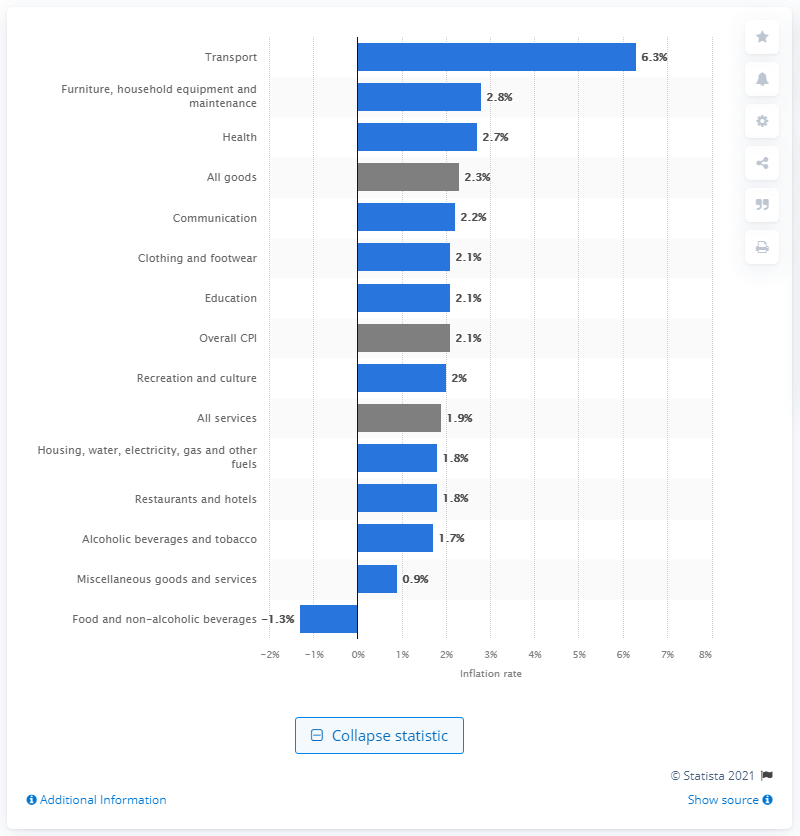Identify some key points in this picture. The prices of furniture, household equipment, and maintenance in May 2021 were significantly higher by 2.8% compared to the previous month. The transport sector experienced an increase in prices of 6.3% in May 2021 compared to the previous year. 